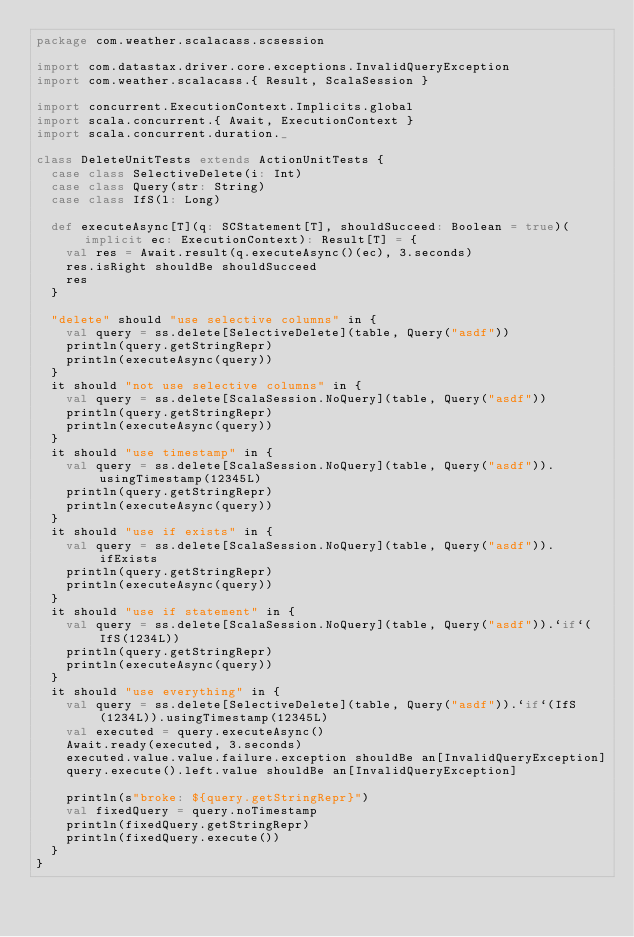Convert code to text. <code><loc_0><loc_0><loc_500><loc_500><_Scala_>package com.weather.scalacass.scsession

import com.datastax.driver.core.exceptions.InvalidQueryException
import com.weather.scalacass.{ Result, ScalaSession }

import concurrent.ExecutionContext.Implicits.global
import scala.concurrent.{ Await, ExecutionContext }
import scala.concurrent.duration._

class DeleteUnitTests extends ActionUnitTests {
  case class SelectiveDelete(i: Int)
  case class Query(str: String)
  case class IfS(l: Long)

  def executeAsync[T](q: SCStatement[T], shouldSucceed: Boolean = true)(implicit ec: ExecutionContext): Result[T] = {
    val res = Await.result(q.executeAsync()(ec), 3.seconds)
    res.isRight shouldBe shouldSucceed
    res
  }

  "delete" should "use selective columns" in {
    val query = ss.delete[SelectiveDelete](table, Query("asdf"))
    println(query.getStringRepr)
    println(executeAsync(query))
  }
  it should "not use selective columns" in {
    val query = ss.delete[ScalaSession.NoQuery](table, Query("asdf"))
    println(query.getStringRepr)
    println(executeAsync(query))
  }
  it should "use timestamp" in {
    val query = ss.delete[ScalaSession.NoQuery](table, Query("asdf")).usingTimestamp(12345L)
    println(query.getStringRepr)
    println(executeAsync(query))
  }
  it should "use if exists" in {
    val query = ss.delete[ScalaSession.NoQuery](table, Query("asdf")).ifExists
    println(query.getStringRepr)
    println(executeAsync(query))
  }
  it should "use if statement" in {
    val query = ss.delete[ScalaSession.NoQuery](table, Query("asdf")).`if`(IfS(1234L))
    println(query.getStringRepr)
    println(executeAsync(query))
  }
  it should "use everything" in {
    val query = ss.delete[SelectiveDelete](table, Query("asdf")).`if`(IfS(1234L)).usingTimestamp(12345L)
    val executed = query.executeAsync()
    Await.ready(executed, 3.seconds)
    executed.value.value.failure.exception shouldBe an[InvalidQueryException]
    query.execute().left.value shouldBe an[InvalidQueryException]

    println(s"broke: ${query.getStringRepr}")
    val fixedQuery = query.noTimestamp
    println(fixedQuery.getStringRepr)
    println(fixedQuery.execute())
  }
}
</code> 